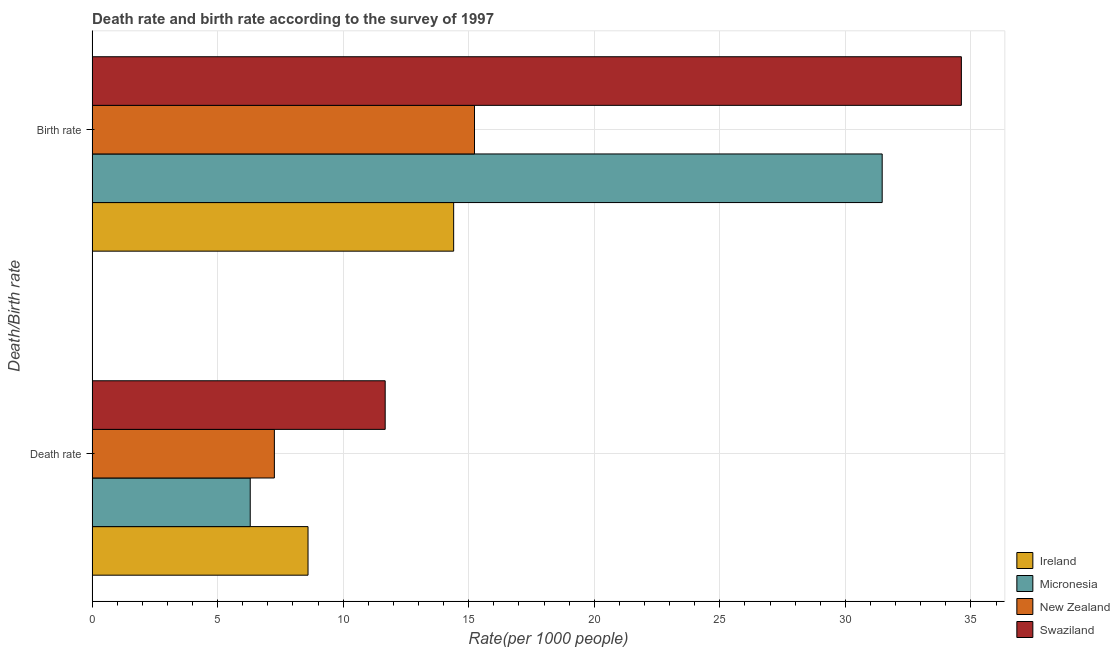Are the number of bars on each tick of the Y-axis equal?
Your response must be concise. Yes. What is the label of the 1st group of bars from the top?
Your answer should be compact. Birth rate. What is the birth rate in Micronesia?
Keep it short and to the point. 31.47. Across all countries, what is the maximum death rate?
Provide a succinct answer. 11.67. Across all countries, what is the minimum death rate?
Make the answer very short. 6.3. In which country was the death rate maximum?
Your answer should be compact. Swaziland. In which country was the birth rate minimum?
Make the answer very short. Ireland. What is the total birth rate in the graph?
Provide a succinct answer. 95.72. What is the difference between the death rate in Micronesia and that in Swaziland?
Your answer should be compact. -5.38. What is the difference between the birth rate in Micronesia and the death rate in New Zealand?
Provide a short and direct response. 24.21. What is the average birth rate per country?
Keep it short and to the point. 23.93. What is the difference between the birth rate and death rate in Swaziland?
Your answer should be compact. 22.95. What is the ratio of the birth rate in New Zealand to that in Ireland?
Your response must be concise. 1.06. In how many countries, is the birth rate greater than the average birth rate taken over all countries?
Make the answer very short. 2. What does the 2nd bar from the top in Death rate represents?
Your answer should be compact. New Zealand. What does the 3rd bar from the bottom in Birth rate represents?
Make the answer very short. New Zealand. Are all the bars in the graph horizontal?
Provide a short and direct response. Yes. How many countries are there in the graph?
Offer a very short reply. 4. Are the values on the major ticks of X-axis written in scientific E-notation?
Provide a short and direct response. No. Does the graph contain any zero values?
Your response must be concise. No. Where does the legend appear in the graph?
Ensure brevity in your answer.  Bottom right. How are the legend labels stacked?
Ensure brevity in your answer.  Vertical. What is the title of the graph?
Give a very brief answer. Death rate and birth rate according to the survey of 1997. Does "Syrian Arab Republic" appear as one of the legend labels in the graph?
Your answer should be compact. No. What is the label or title of the X-axis?
Offer a terse response. Rate(per 1000 people). What is the label or title of the Y-axis?
Your response must be concise. Death/Birth rate. What is the Rate(per 1000 people) of Ireland in Death rate?
Offer a terse response. 8.6. What is the Rate(per 1000 people) in Micronesia in Death rate?
Provide a succinct answer. 6.3. What is the Rate(per 1000 people) in New Zealand in Death rate?
Ensure brevity in your answer.  7.26. What is the Rate(per 1000 people) in Swaziland in Death rate?
Keep it short and to the point. 11.67. What is the Rate(per 1000 people) of Ireland in Birth rate?
Give a very brief answer. 14.4. What is the Rate(per 1000 people) in Micronesia in Birth rate?
Offer a terse response. 31.47. What is the Rate(per 1000 people) of New Zealand in Birth rate?
Your answer should be very brief. 15.23. What is the Rate(per 1000 people) in Swaziland in Birth rate?
Give a very brief answer. 34.62. Across all Death/Birth rate, what is the maximum Rate(per 1000 people) in Micronesia?
Your response must be concise. 31.47. Across all Death/Birth rate, what is the maximum Rate(per 1000 people) of New Zealand?
Your answer should be very brief. 15.23. Across all Death/Birth rate, what is the maximum Rate(per 1000 people) in Swaziland?
Provide a succinct answer. 34.62. Across all Death/Birth rate, what is the minimum Rate(per 1000 people) of Ireland?
Offer a terse response. 8.6. Across all Death/Birth rate, what is the minimum Rate(per 1000 people) in Micronesia?
Your response must be concise. 6.3. Across all Death/Birth rate, what is the minimum Rate(per 1000 people) in New Zealand?
Your answer should be very brief. 7.26. Across all Death/Birth rate, what is the minimum Rate(per 1000 people) of Swaziland?
Your response must be concise. 11.67. What is the total Rate(per 1000 people) of Ireland in the graph?
Keep it short and to the point. 23. What is the total Rate(per 1000 people) in Micronesia in the graph?
Keep it short and to the point. 37.77. What is the total Rate(per 1000 people) of New Zealand in the graph?
Offer a very short reply. 22.49. What is the total Rate(per 1000 people) of Swaziland in the graph?
Your response must be concise. 46.29. What is the difference between the Rate(per 1000 people) of Micronesia in Death rate and that in Birth rate?
Make the answer very short. -25.17. What is the difference between the Rate(per 1000 people) in New Zealand in Death rate and that in Birth rate?
Provide a succinct answer. -7.97. What is the difference between the Rate(per 1000 people) in Swaziland in Death rate and that in Birth rate?
Give a very brief answer. -22.95. What is the difference between the Rate(per 1000 people) in Ireland in Death rate and the Rate(per 1000 people) in Micronesia in Birth rate?
Your answer should be compact. -22.87. What is the difference between the Rate(per 1000 people) of Ireland in Death rate and the Rate(per 1000 people) of New Zealand in Birth rate?
Provide a succinct answer. -6.63. What is the difference between the Rate(per 1000 people) of Ireland in Death rate and the Rate(per 1000 people) of Swaziland in Birth rate?
Your answer should be compact. -26.02. What is the difference between the Rate(per 1000 people) of Micronesia in Death rate and the Rate(per 1000 people) of New Zealand in Birth rate?
Keep it short and to the point. -8.93. What is the difference between the Rate(per 1000 people) in Micronesia in Death rate and the Rate(per 1000 people) in Swaziland in Birth rate?
Provide a succinct answer. -28.32. What is the difference between the Rate(per 1000 people) of New Zealand in Death rate and the Rate(per 1000 people) of Swaziland in Birth rate?
Keep it short and to the point. -27.36. What is the average Rate(per 1000 people) of Micronesia per Death/Birth rate?
Offer a very short reply. 18.88. What is the average Rate(per 1000 people) in New Zealand per Death/Birth rate?
Ensure brevity in your answer.  11.24. What is the average Rate(per 1000 people) in Swaziland per Death/Birth rate?
Provide a short and direct response. 23.15. What is the difference between the Rate(per 1000 people) of Ireland and Rate(per 1000 people) of Micronesia in Death rate?
Provide a short and direct response. 2.3. What is the difference between the Rate(per 1000 people) of Ireland and Rate(per 1000 people) of New Zealand in Death rate?
Keep it short and to the point. 1.34. What is the difference between the Rate(per 1000 people) in Ireland and Rate(per 1000 people) in Swaziland in Death rate?
Offer a very short reply. -3.07. What is the difference between the Rate(per 1000 people) of Micronesia and Rate(per 1000 people) of New Zealand in Death rate?
Give a very brief answer. -0.96. What is the difference between the Rate(per 1000 people) of Micronesia and Rate(per 1000 people) of Swaziland in Death rate?
Ensure brevity in your answer.  -5.38. What is the difference between the Rate(per 1000 people) in New Zealand and Rate(per 1000 people) in Swaziland in Death rate?
Your answer should be compact. -4.41. What is the difference between the Rate(per 1000 people) of Ireland and Rate(per 1000 people) of Micronesia in Birth rate?
Your answer should be very brief. -17.07. What is the difference between the Rate(per 1000 people) of Ireland and Rate(per 1000 people) of New Zealand in Birth rate?
Offer a terse response. -0.83. What is the difference between the Rate(per 1000 people) in Ireland and Rate(per 1000 people) in Swaziland in Birth rate?
Make the answer very short. -20.22. What is the difference between the Rate(per 1000 people) in Micronesia and Rate(per 1000 people) in New Zealand in Birth rate?
Ensure brevity in your answer.  16.24. What is the difference between the Rate(per 1000 people) in Micronesia and Rate(per 1000 people) in Swaziland in Birth rate?
Your answer should be compact. -3.15. What is the difference between the Rate(per 1000 people) of New Zealand and Rate(per 1000 people) of Swaziland in Birth rate?
Keep it short and to the point. -19.39. What is the ratio of the Rate(per 1000 people) of Ireland in Death rate to that in Birth rate?
Your answer should be compact. 0.6. What is the ratio of the Rate(per 1000 people) of Micronesia in Death rate to that in Birth rate?
Make the answer very short. 0.2. What is the ratio of the Rate(per 1000 people) in New Zealand in Death rate to that in Birth rate?
Offer a very short reply. 0.48. What is the ratio of the Rate(per 1000 people) of Swaziland in Death rate to that in Birth rate?
Your answer should be very brief. 0.34. What is the difference between the highest and the second highest Rate(per 1000 people) in Micronesia?
Offer a terse response. 25.17. What is the difference between the highest and the second highest Rate(per 1000 people) of New Zealand?
Give a very brief answer. 7.97. What is the difference between the highest and the second highest Rate(per 1000 people) of Swaziland?
Offer a terse response. 22.95. What is the difference between the highest and the lowest Rate(per 1000 people) of Micronesia?
Ensure brevity in your answer.  25.17. What is the difference between the highest and the lowest Rate(per 1000 people) in New Zealand?
Your answer should be compact. 7.97. What is the difference between the highest and the lowest Rate(per 1000 people) of Swaziland?
Your answer should be compact. 22.95. 